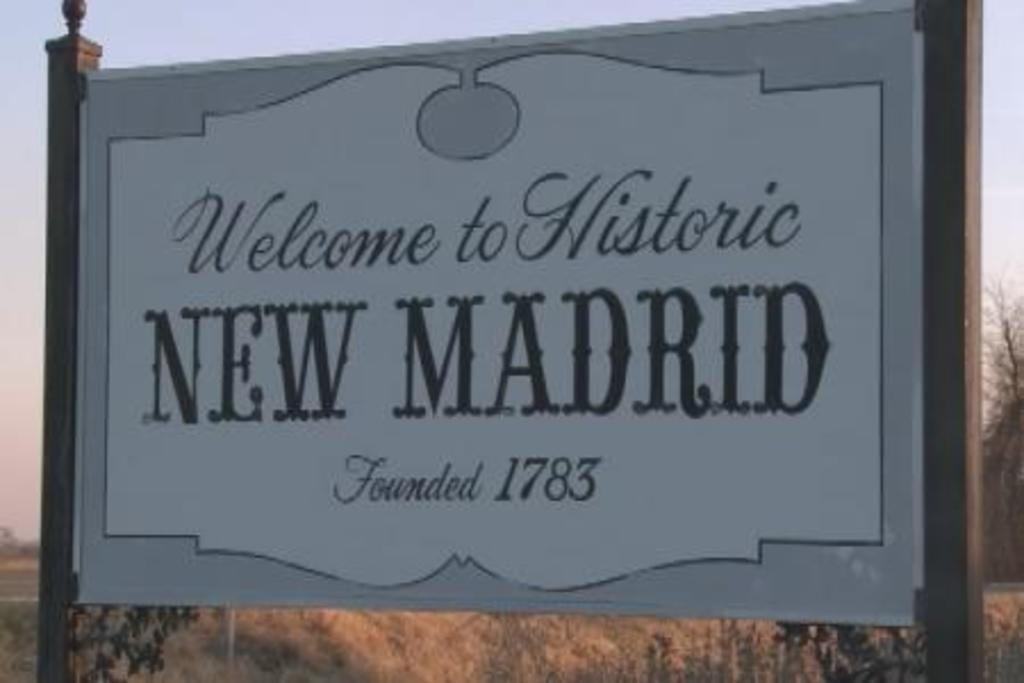<image>
Summarize the visual content of the image. A sign saying "Welcome to New Madrid, Founded 1783". 